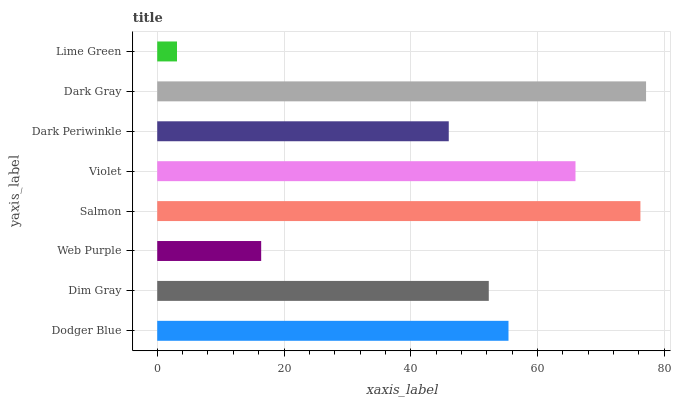Is Lime Green the minimum?
Answer yes or no. Yes. Is Dark Gray the maximum?
Answer yes or no. Yes. Is Dim Gray the minimum?
Answer yes or no. No. Is Dim Gray the maximum?
Answer yes or no. No. Is Dodger Blue greater than Dim Gray?
Answer yes or no. Yes. Is Dim Gray less than Dodger Blue?
Answer yes or no. Yes. Is Dim Gray greater than Dodger Blue?
Answer yes or no. No. Is Dodger Blue less than Dim Gray?
Answer yes or no. No. Is Dodger Blue the high median?
Answer yes or no. Yes. Is Dim Gray the low median?
Answer yes or no. Yes. Is Dim Gray the high median?
Answer yes or no. No. Is Salmon the low median?
Answer yes or no. No. 